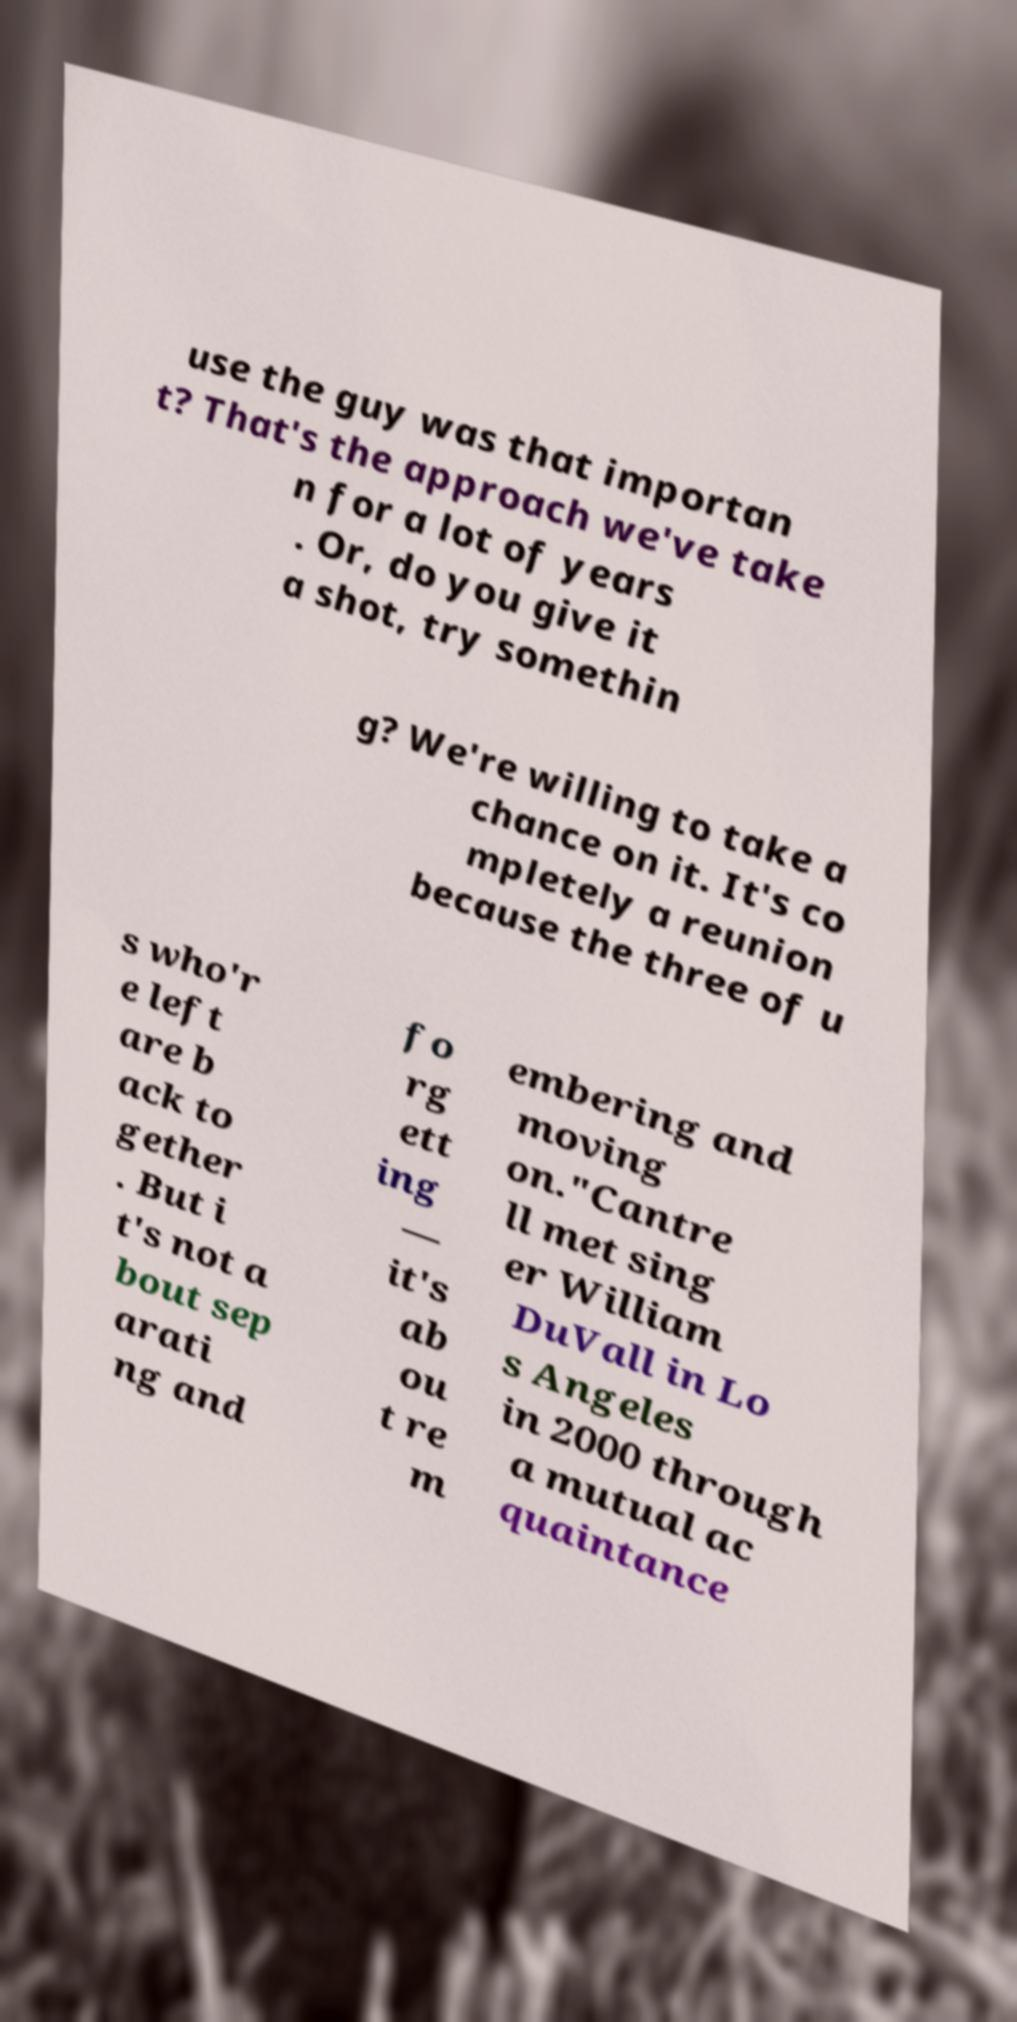What messages or text are displayed in this image? I need them in a readable, typed format. use the guy was that importan t? That's the approach we've take n for a lot of years . Or, do you give it a shot, try somethin g? We're willing to take a chance on it. It's co mpletely a reunion because the three of u s who'r e left are b ack to gether . But i t's not a bout sep arati ng and fo rg ett ing — it's ab ou t re m embering and moving on."Cantre ll met sing er William DuVall in Lo s Angeles in 2000 through a mutual ac quaintance 